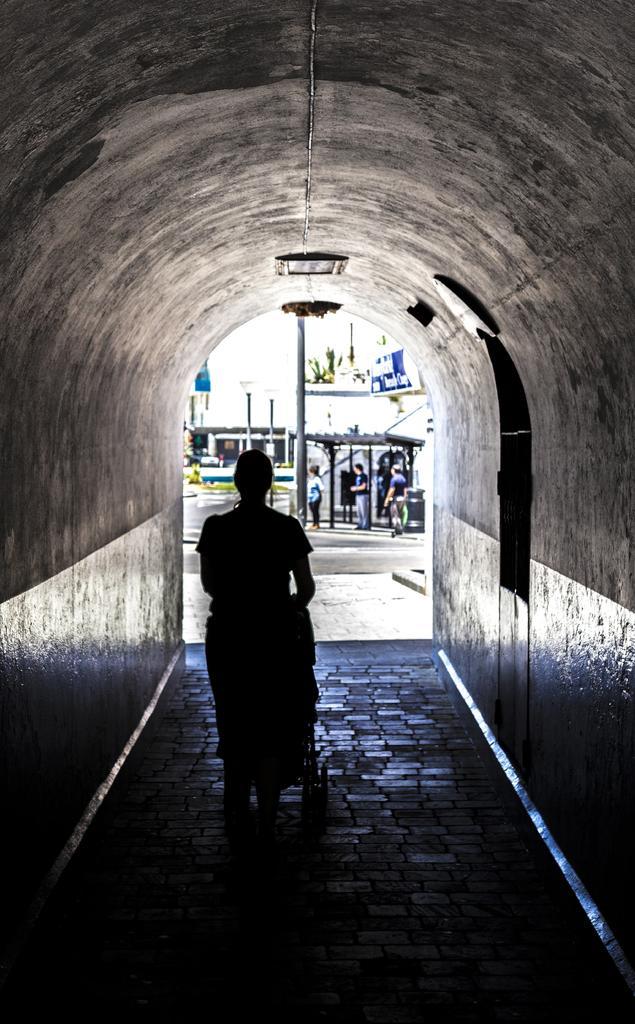Describe this image in one or two sentences. In this image I can see the person inside the tunnel. In the background I can see few more people standing to the side of the pole. I can also see the shed, banner and there is a white background. 